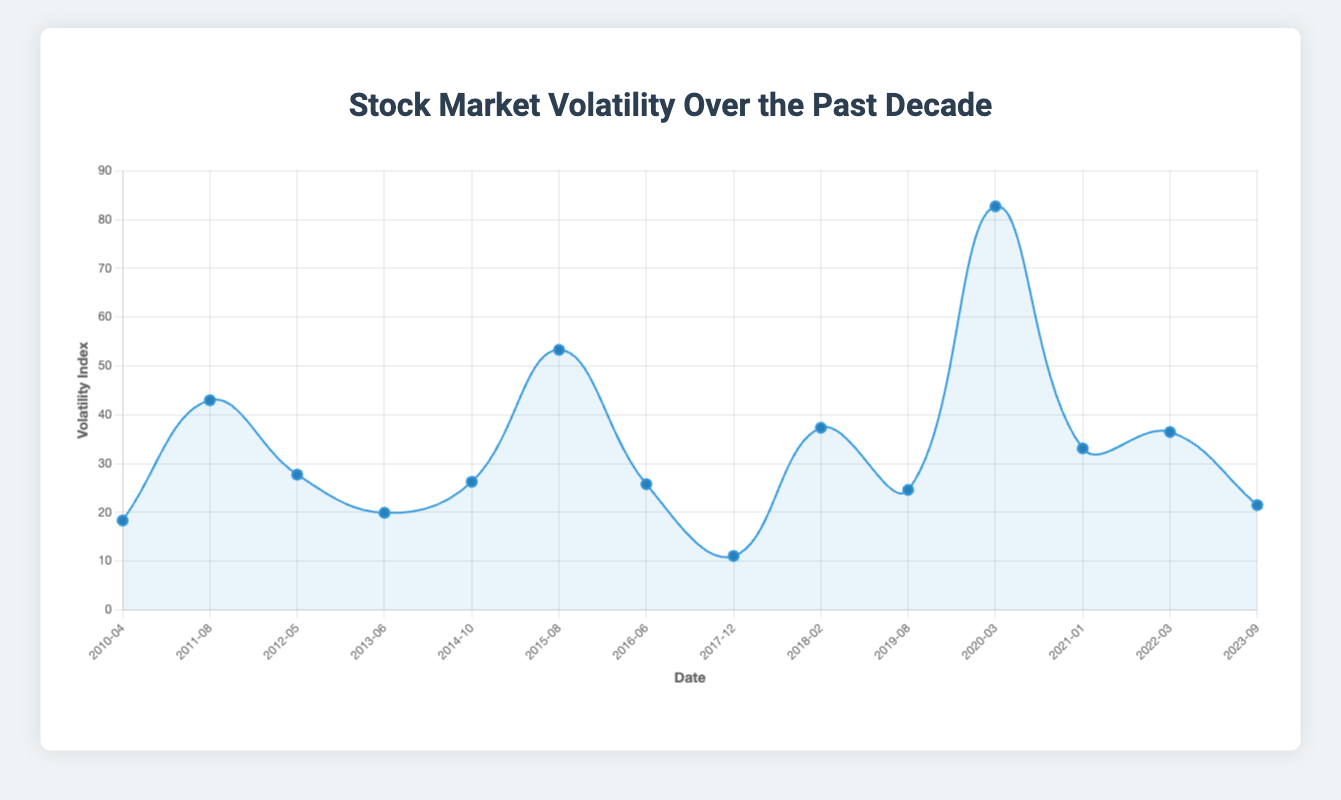What major financial event corresponds with the highest spike in volatility? Look for the highest point on the line plot and then identify the corresponding event label. The highest spike is in March 2020, which corresponds to the COVID-19 Pandemic.
Answer: COVID-19 Pandemic Which two events show the largest drop in volatility between them? Identify the largest decrease in volatility by observing the steepest downward slope between two events on the line plot. The biggest drop is between August 2015 (China's Market Crash) and December 2017 (Crypto Boom).
Answer: China's Market Crash and Crypto Boom What is the average volatility index from 2010 to 2015? Sum the volatility index values from 2010-04 to 2015-08 and divide by the number of events, which is 6. (18.32 + 42.96 + 27.73 + 19.89 + 26.25 + 53.29) / 6 = 31.407.
Answer: 31.407 How does the volatility during the US Credit Rating Downgrade in 2011 compare to the COVID-19 Pandemic in 2020? Compare the volatility index values for these two events from the chart. The volatility index in 2011 is 42.96 while in 2020 it is 82.69, which means the 2020 event had significantly higher volatility.
Answer: Higher in 2020 Which event had a volatility index closest to 30? Identify the event closest to the value of 30 by checking the volatility index values on the chart. US Fiscal Cliff in May 2012 has a volatility index of 27.73, which is closest to 30.
Answer: US Fiscal Cliff What is the median volatility index for all events listed? First, list all volatility values: 18.32, 42.96, 27.73, 19.89, 26.25, 53.29, 25.76, 11.04, 37.32, 24.59, 82.69, 33.09, 36.45, 21.47. Sort them: 11.04, 18.32, 19.89, 21.47, 24.59, 25.76, 26.25, 27.73, 33.09, 36.45, 37.32, 42.96, 53.29, 82.69. The median, being the average of the 7th and 8th values in the sorted list, is (26.25 + 27.73) / 2 = 26.99.
Answer: 26.99 How many times did the volatility index exceed 40? Count the number of points on the plot where the volatility index is greater than 40. The points are in August 2011, August 2015, February 2018, March 2020. This occurs 4 times.
Answer: 4 times 